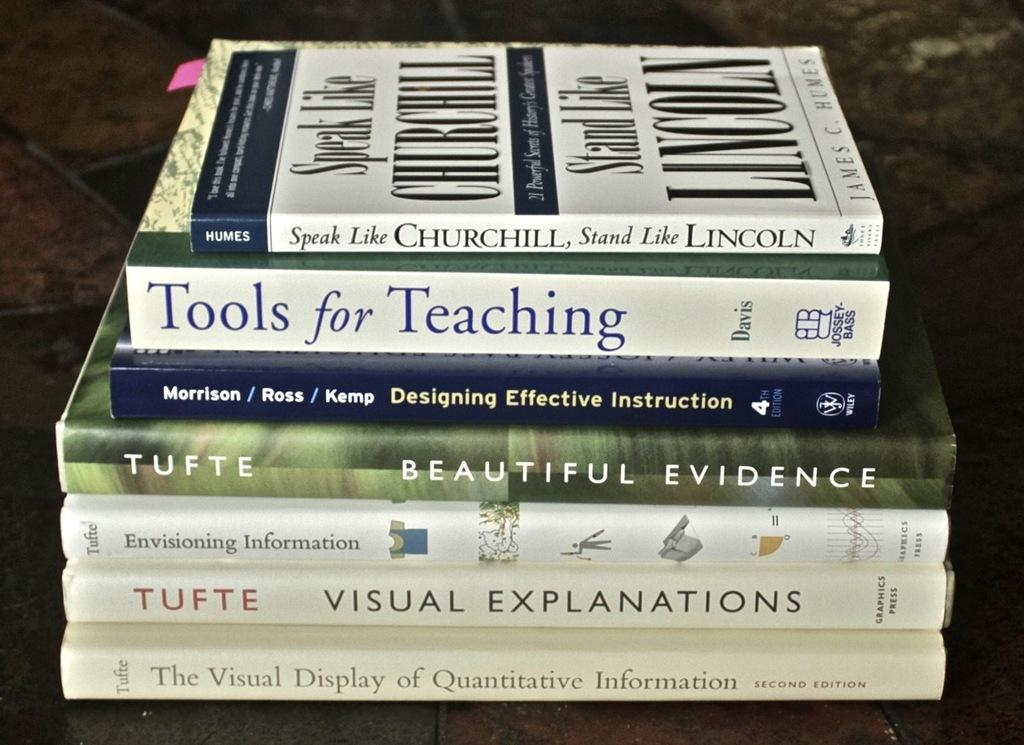<image>
Create a compact narrative representing the image presented. Books stacked on top of each other on a table that include visual information 